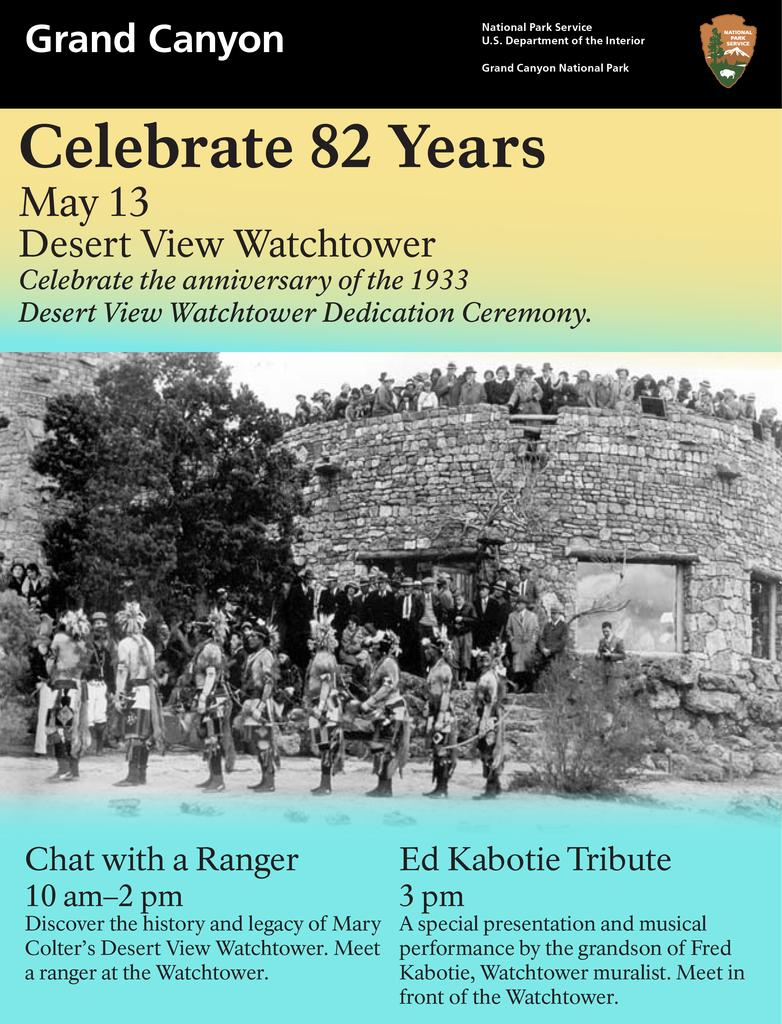Provide a one-sentence caption for the provided image. 82 years celebratory poster for the grand canyon lists events people can attend. 